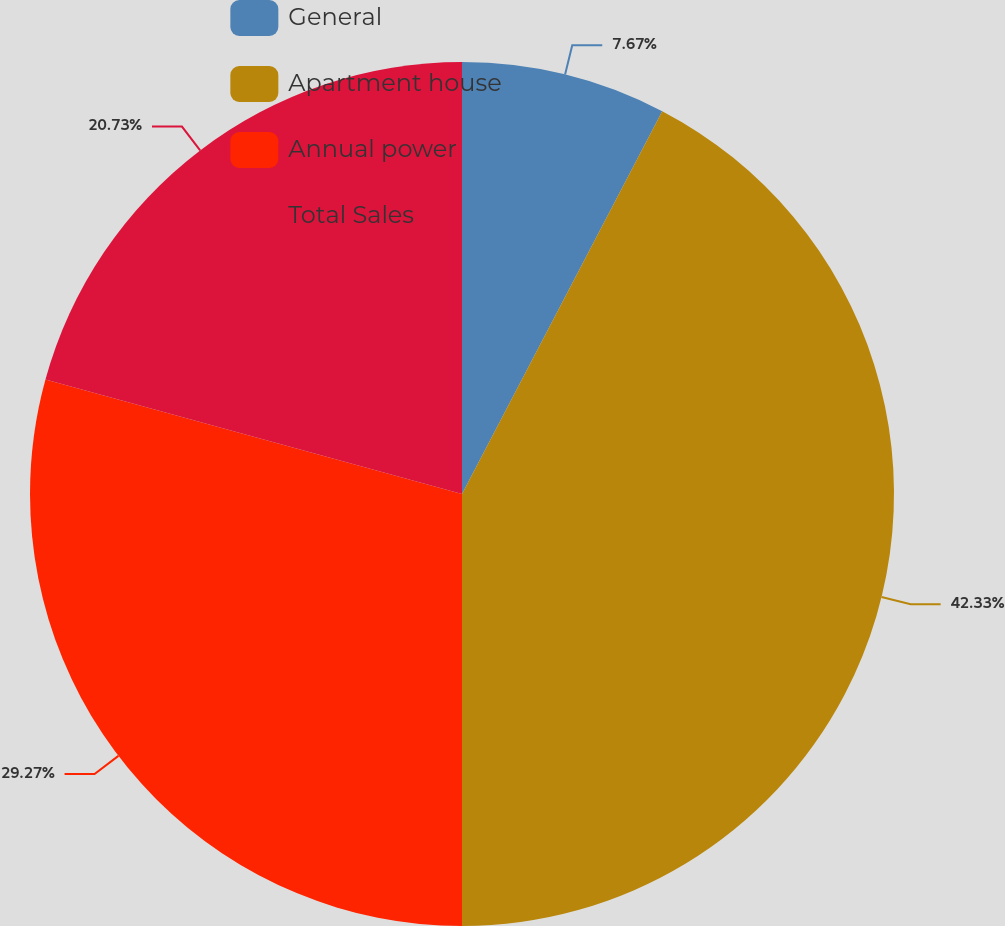Convert chart to OTSL. <chart><loc_0><loc_0><loc_500><loc_500><pie_chart><fcel>General<fcel>Apartment house<fcel>Annual power<fcel>Total Sales<nl><fcel>7.67%<fcel>42.33%<fcel>29.27%<fcel>20.73%<nl></chart> 